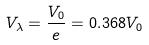Convert formula to latex. <formula><loc_0><loc_0><loc_500><loc_500>V _ { \lambda } = \frac { V _ { 0 } } { e } = 0 . 3 6 8 V _ { 0 }</formula> 